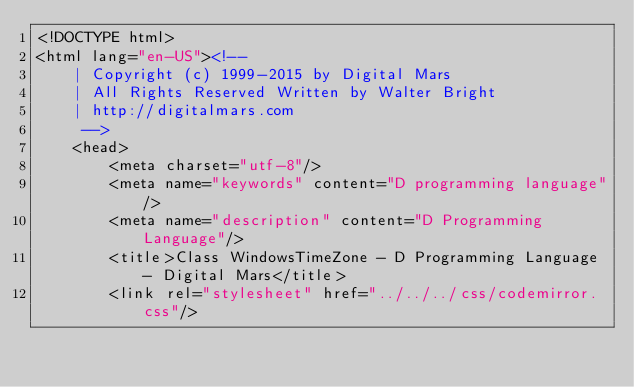<code> <loc_0><loc_0><loc_500><loc_500><_HTML_><!DOCTYPE html>
<html lang="en-US"><!-- 
    | Copyright (c) 1999-2015 by Digital Mars
    | All Rights Reserved Written by Walter Bright
    | http://digitalmars.com
	 -->
	<head>
		<meta charset="utf-8"/>
		<meta name="keywords" content="D programming language"/>
		<meta name="description" content="D Programming Language"/>
		<title>Class WindowsTimeZone - D Programming Language - Digital Mars</title>
		<link rel="stylesheet" href="../../../css/codemirror.css"/></code> 